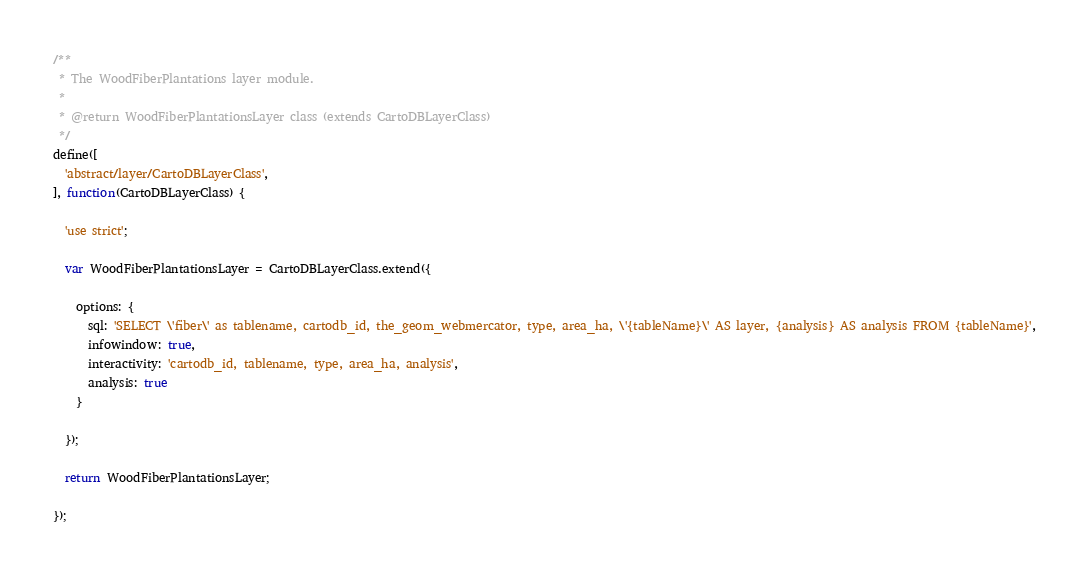Convert code to text. <code><loc_0><loc_0><loc_500><loc_500><_JavaScript_>/**
 * The WoodFiberPlantations layer module.
 *
 * @return WoodFiberPlantationsLayer class (extends CartoDBLayerClass)
 */
define([
  'abstract/layer/CartoDBLayerClass',
], function(CartoDBLayerClass) {

  'use strict';

  var WoodFiberPlantationsLayer = CartoDBLayerClass.extend({

    options: {
      sql: 'SELECT \'fiber\' as tablename, cartodb_id, the_geom_webmercator, type, area_ha, \'{tableName}\' AS layer, {analysis} AS analysis FROM {tableName}',
      infowindow: true,
      interactivity: 'cartodb_id, tablename, type, area_ha, analysis',
      analysis: true
    }

  });

  return WoodFiberPlantationsLayer;

});
</code> 